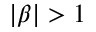Convert formula to latex. <formula><loc_0><loc_0><loc_500><loc_500>| \beta | > 1</formula> 